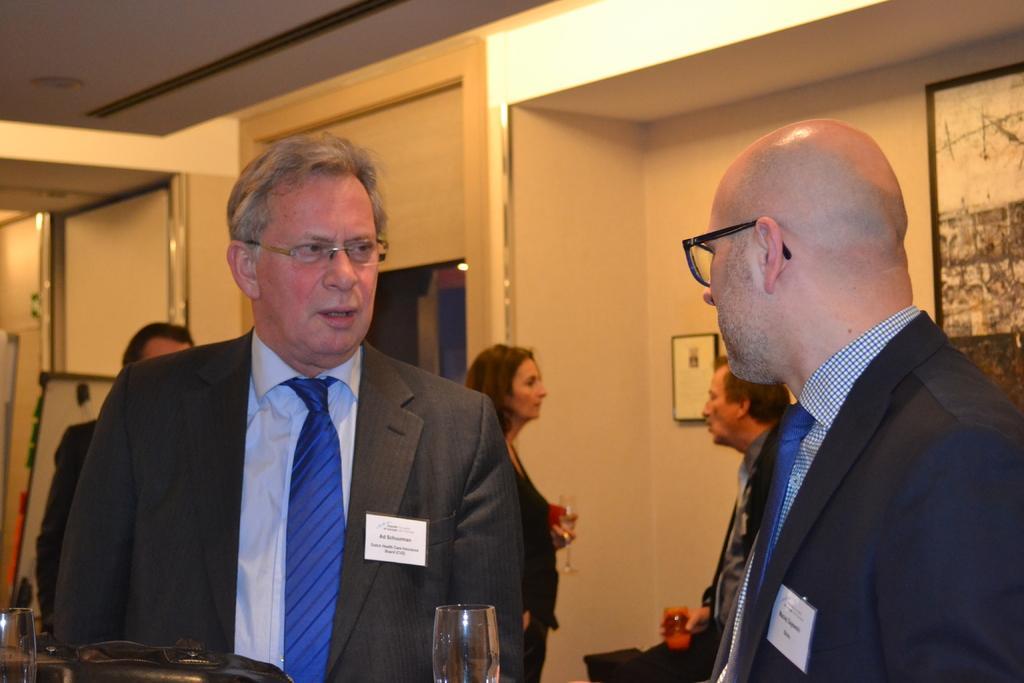Please provide a concise description of this image. In this image I can see a group of people standing in a hall in which few of them holding glasses, behind them there is a wall with some photo frames. 